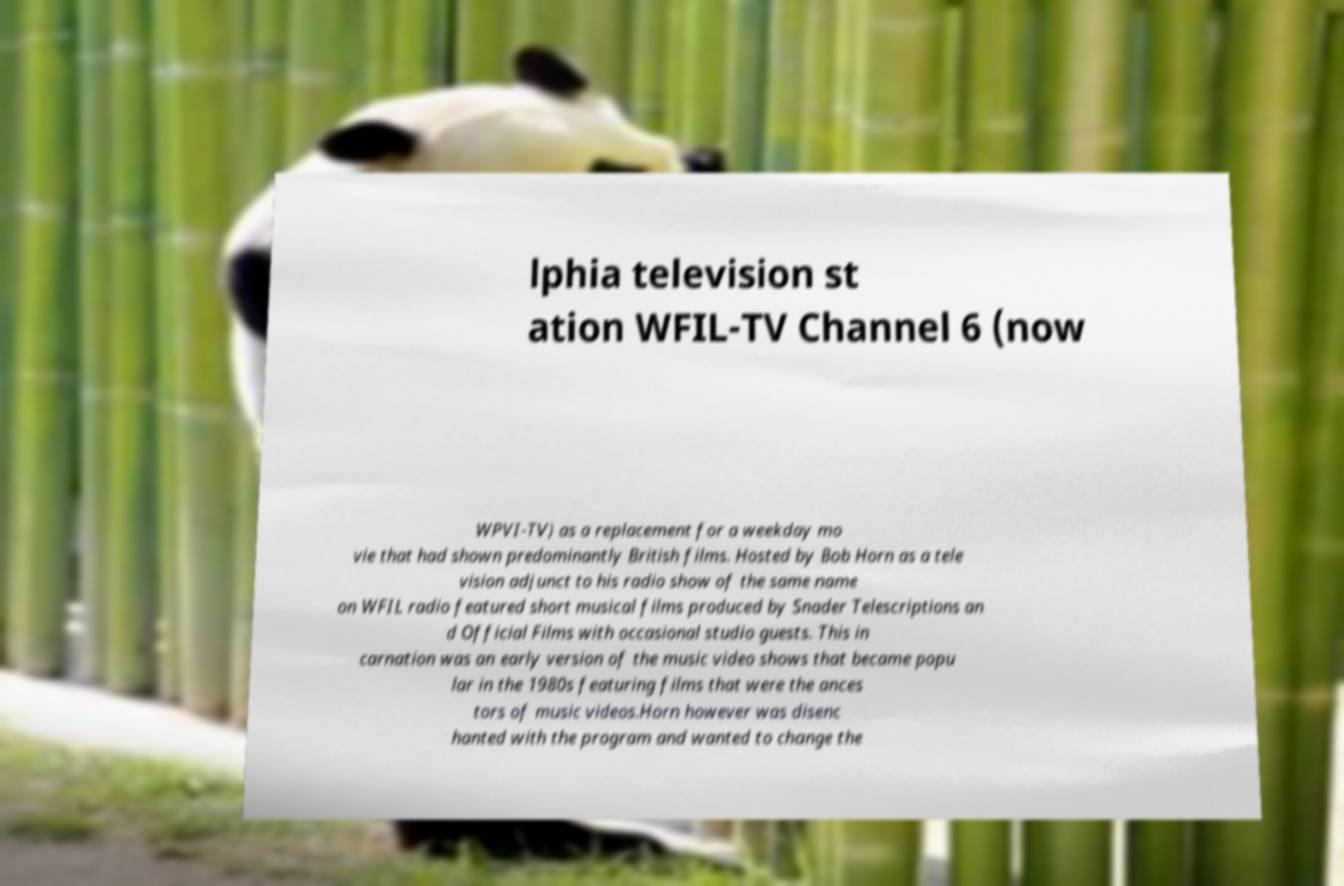Please identify and transcribe the text found in this image. lphia television st ation WFIL-TV Channel 6 (now WPVI-TV) as a replacement for a weekday mo vie that had shown predominantly British films. Hosted by Bob Horn as a tele vision adjunct to his radio show of the same name on WFIL radio featured short musical films produced by Snader Telescriptions an d Official Films with occasional studio guests. This in carnation was an early version of the music video shows that became popu lar in the 1980s featuring films that were the ances tors of music videos.Horn however was disenc hanted with the program and wanted to change the 